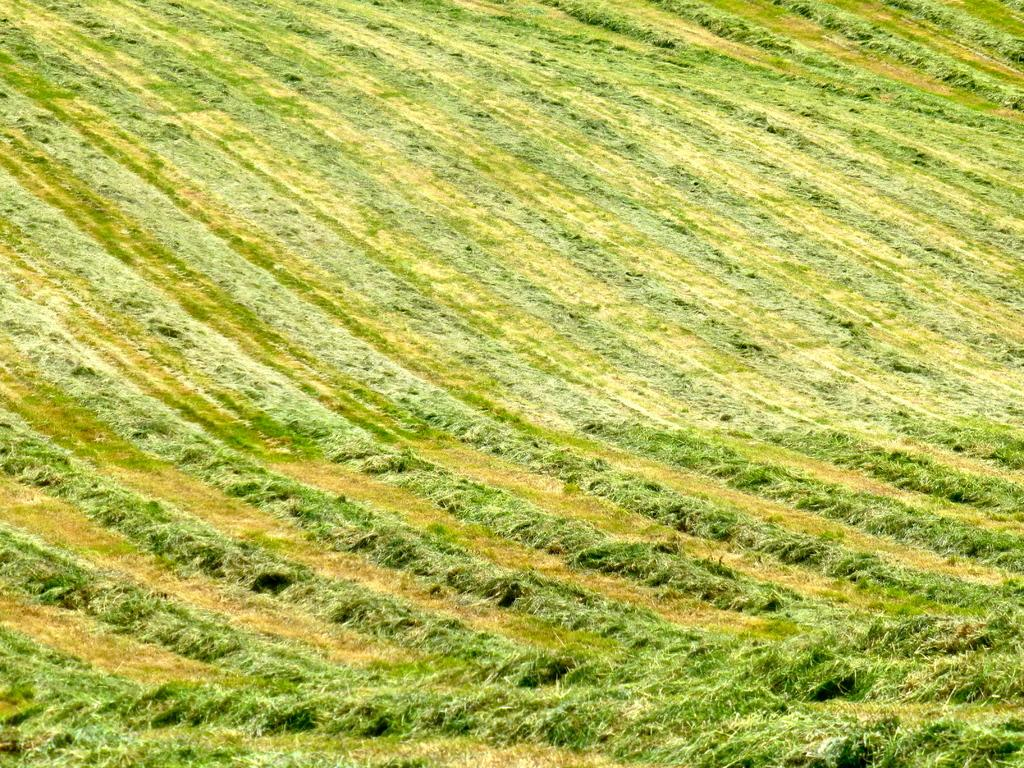What type of vegetation is present in the image? There is grass in the image. What color is the grass in the image? The grass is green in color. What position does the maid hold in the image? There is no maid present in the image, so it is not possible to determine the position they might hold. 